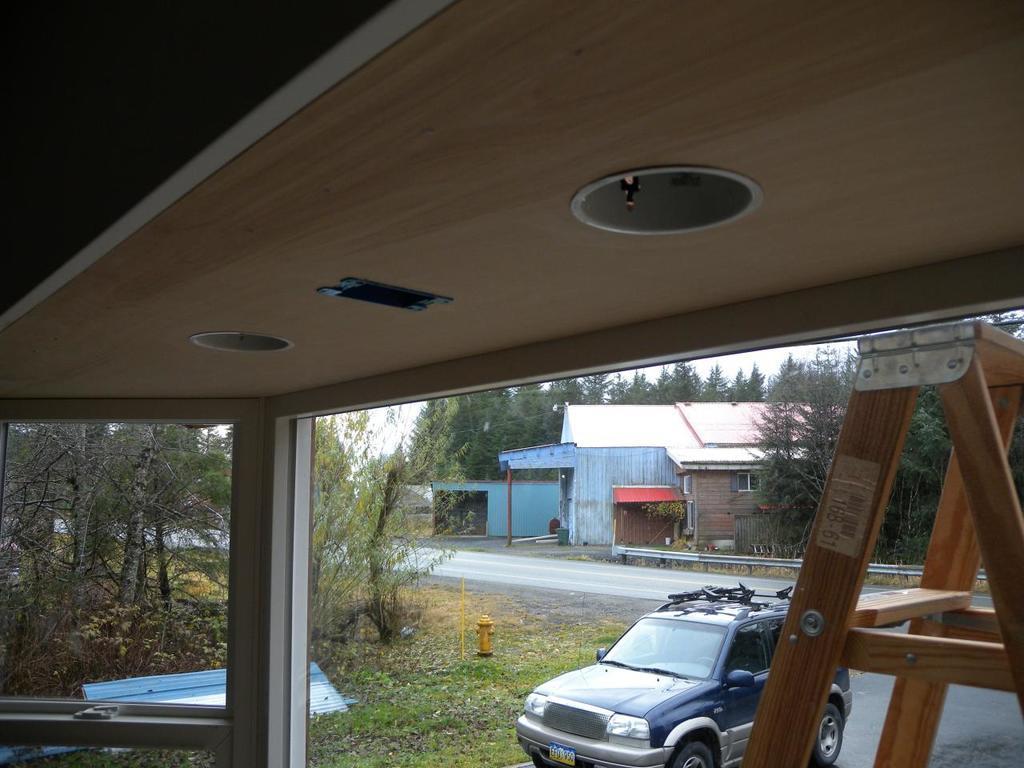How would you summarize this image in a sentence or two? In this image in front there is a rooftop with the pillar. There is a ladder. There is a car on the road. On the left side of the image there is grass on the surface. In the background of the image there are trees, buildings and sky. There is a water pipe. 